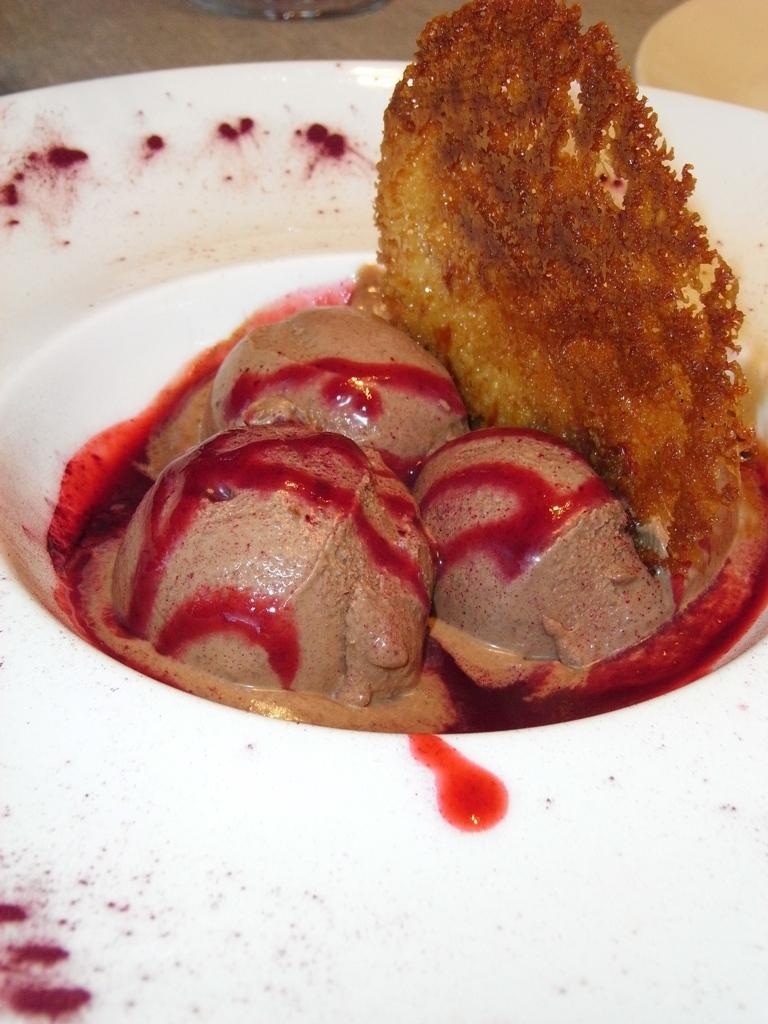What is present on the plate in the image? The facts provided do not mention any details about the plate. What is in the bowl in the image? There is ice cream in the bowl. What is the main subject of the image? The main subject of the image is the bowl with ice cream. What can be seen in the background of the image? There are objects in the background of the image. Are there any fairies flying around the ice cream in the image? No, there are no fairies present in the image. Does the sister of the person who took the image appear in the photo? The facts provided do not mention any details about the person who took the image or their relatives. 